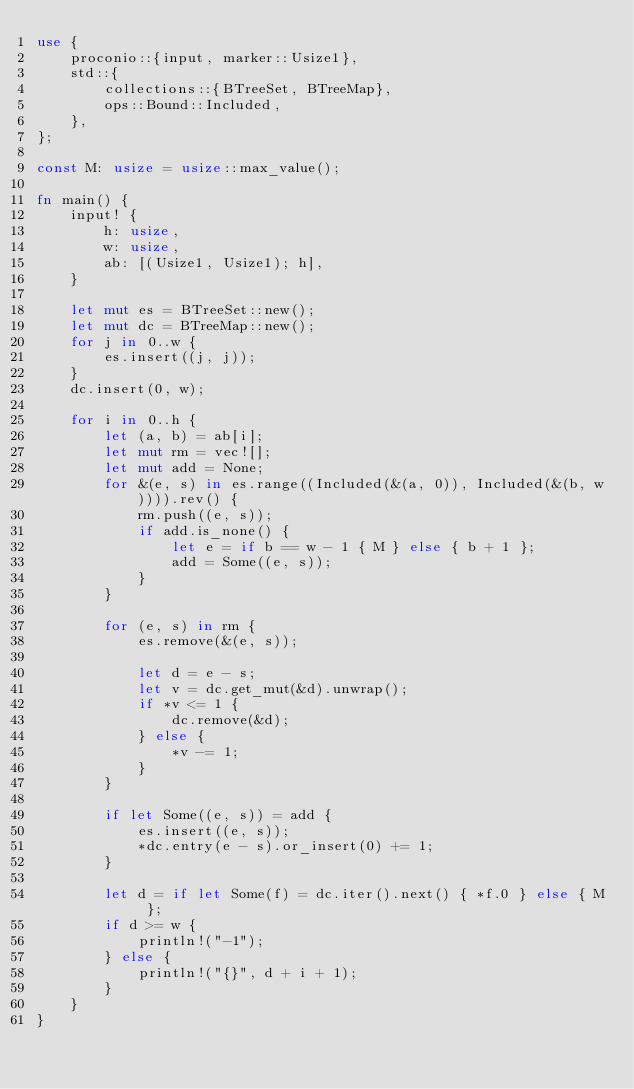Convert code to text. <code><loc_0><loc_0><loc_500><loc_500><_Rust_>use {
    proconio::{input, marker::Usize1},
    std::{
        collections::{BTreeSet, BTreeMap},
        ops::Bound::Included,
    },
};

const M: usize = usize::max_value();

fn main() {
    input! {
        h: usize,
        w: usize,
        ab: [(Usize1, Usize1); h],
    }

    let mut es = BTreeSet::new();
    let mut dc = BTreeMap::new();
    for j in 0..w {
        es.insert((j, j));
    }
    dc.insert(0, w);

    for i in 0..h {
        let (a, b) = ab[i];
        let mut rm = vec![];
        let mut add = None;
        for &(e, s) in es.range((Included(&(a, 0)), Included(&(b, w)))).rev() {
            rm.push((e, s));
            if add.is_none() {
                let e = if b == w - 1 { M } else { b + 1 };
                add = Some((e, s));
            }
        }

        for (e, s) in rm {
            es.remove(&(e, s));

            let d = e - s;
            let v = dc.get_mut(&d).unwrap();
            if *v <= 1 {
                dc.remove(&d);
            } else {
                *v -= 1;
            }
        }

        if let Some((e, s)) = add {
            es.insert((e, s));
            *dc.entry(e - s).or_insert(0) += 1;
        }

        let d = if let Some(f) = dc.iter().next() { *f.0 } else { M };
        if d >= w {
            println!("-1");
        } else {
            println!("{}", d + i + 1);
        }
    }
}
</code> 